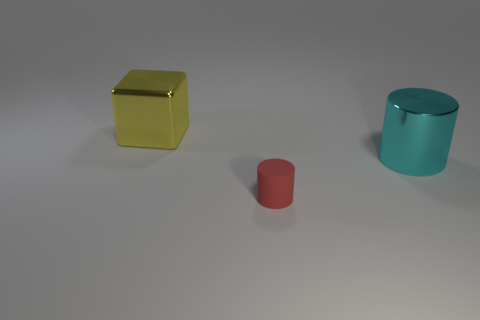Add 2 blue metallic cylinders. How many objects exist? 5 Subtract all blocks. How many objects are left? 2 Add 1 cylinders. How many cylinders are left? 3 Add 2 large yellow cubes. How many large yellow cubes exist? 3 Subtract 0 cyan cubes. How many objects are left? 3 Subtract all large cyan metallic things. Subtract all brown matte things. How many objects are left? 2 